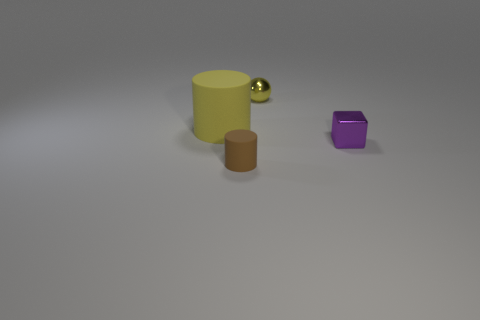Add 3 matte cubes. How many objects exist? 7 Subtract all cubes. How many objects are left? 3 Subtract 1 yellow balls. How many objects are left? 3 Subtract all tiny gray rubber cylinders. Subtract all tiny yellow balls. How many objects are left? 3 Add 3 purple blocks. How many purple blocks are left? 4 Add 2 big gray cylinders. How many big gray cylinders exist? 2 